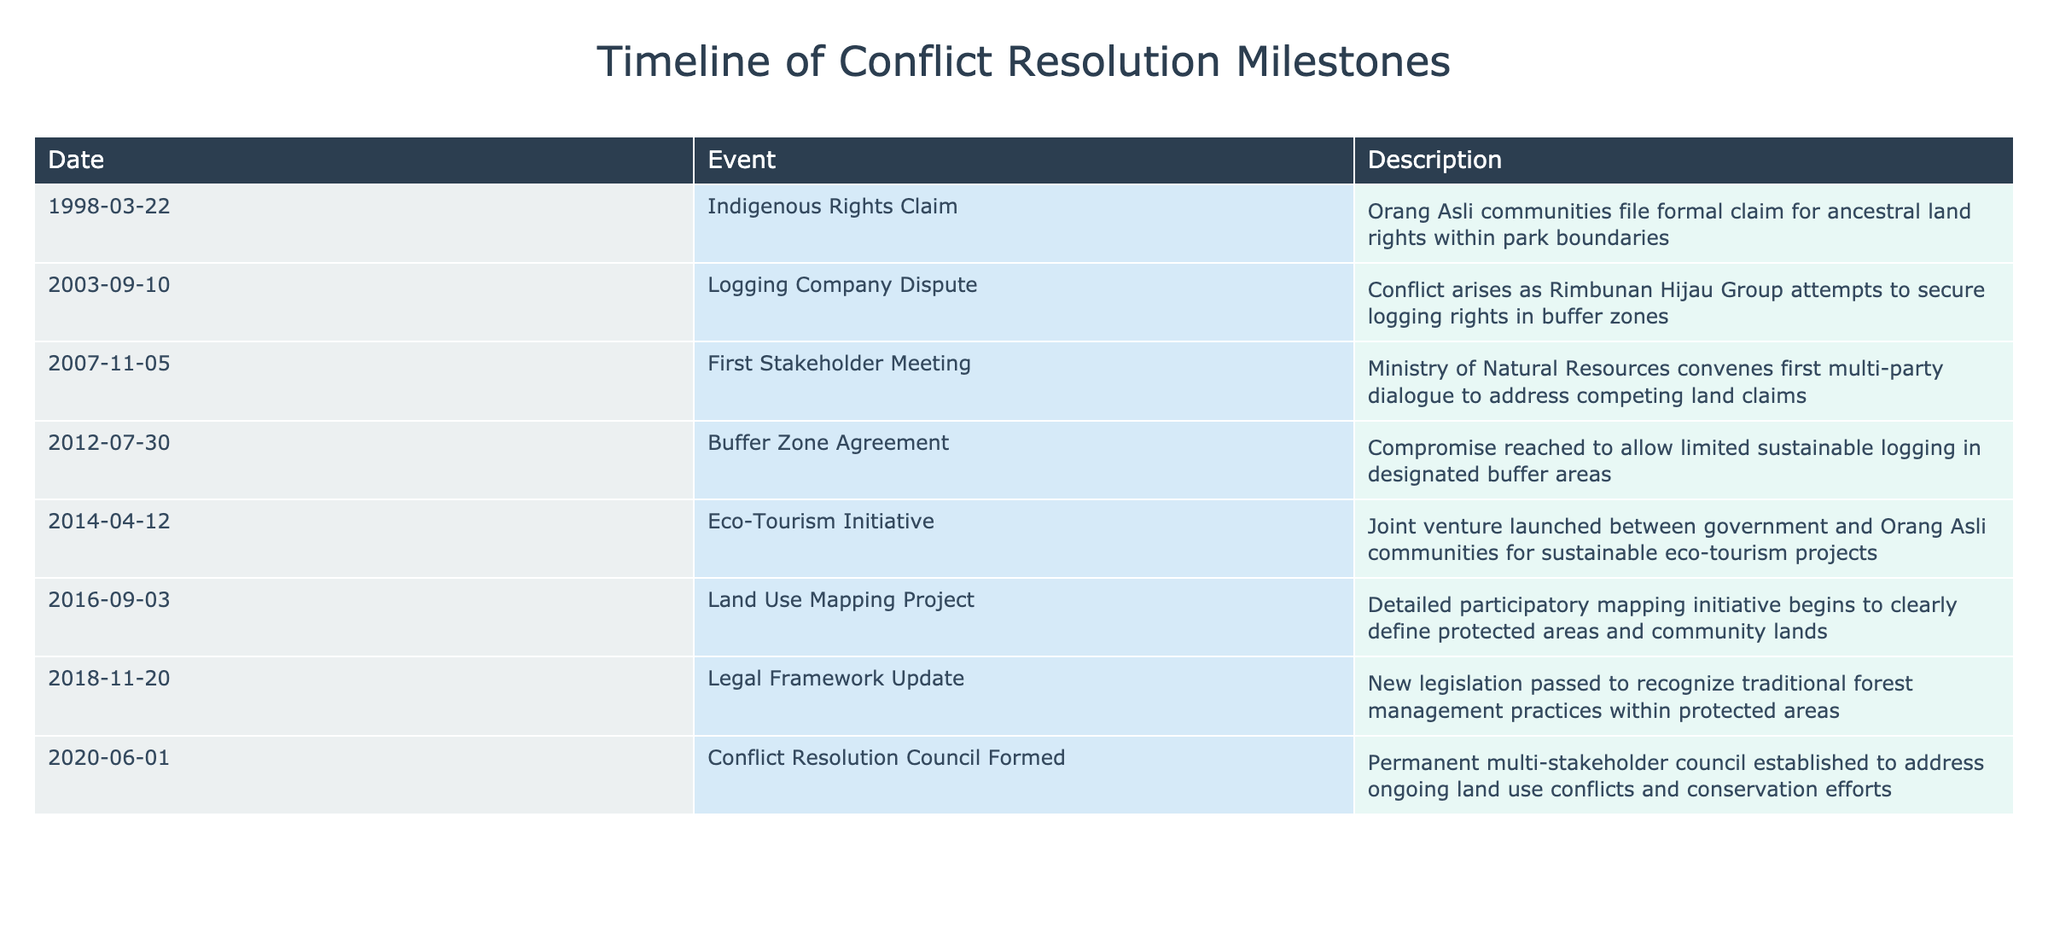What event marked the first formal claim for ancestral land rights? The first formal claim for ancestral land rights was filed by Orang Asli communities on March 22, 1998, according to the table.
Answer: Indigenous Rights Claim What year did the Buffer Zone Agreement take place? The Buffer Zone Agreement occurred on July 30, 2012, as shown in the event date.
Answer: 2012 How many years passed between the first stakeholder meeting and the formation of the Conflict Resolution Council? The first stakeholder meeting took place in 2007 and the Conflict Resolution Council was formed in 2020. Therefore, the difference in years is 2020 - 2007 = 13 years.
Answer: 13 years Was there an event related to eco-tourism development? Yes, the table indicates that an eco-tourism initiative was launched on April 12, 2014, in cooperation between the government and Orang Asli communities.
Answer: Yes What is the significance of the Legal Framework Update that occurred in 2018? The Legal Framework Update on November 20, 2018, was significant because it included new legislation to recognize traditional forest management practices within protected areas, thereby validating the roles of local communities in conservation.
Answer: Recognition of traditional practices Which event identified efforts to clearly define protected areas? The Land Use Mapping Project, which began on September 3, 2016, focused on participatory mapping to clarify protected and community land.
Answer: Land Use Mapping Project What was the outcome of the dispute involving the logging company? The logging company dispute escalated when Rimbunan Hijau Group attempted to secure rights in buffer zones, indicating ongoing tensions in land use negotiations.
Answer: Tension due to logging rights How many significant events occurred related to conflict resolution from 1998 to 2020? Counting all events in the table between these years, there are a total of 8 significant events related to conflict resolution measures.
Answer: 8 events 